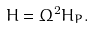Convert formula to latex. <formula><loc_0><loc_0><loc_500><loc_500>H = \Omega ^ { 2 } H _ { P } .</formula> 